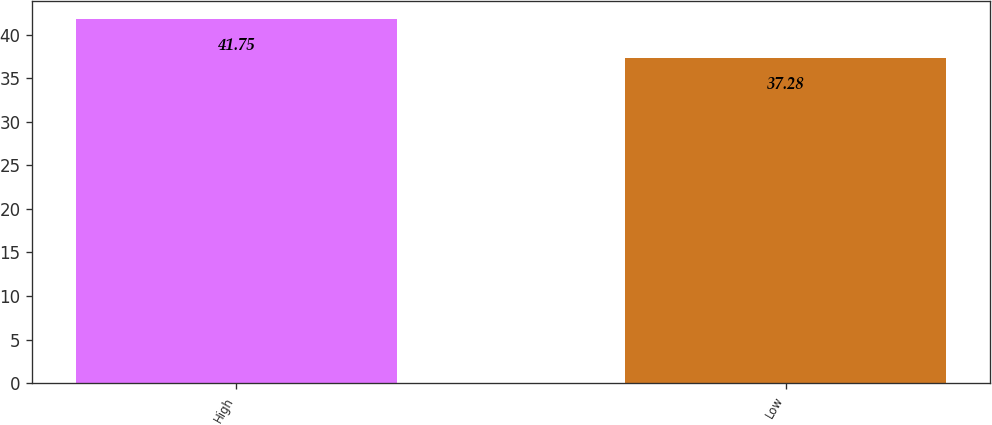Convert chart to OTSL. <chart><loc_0><loc_0><loc_500><loc_500><bar_chart><fcel>High<fcel>Low<nl><fcel>41.75<fcel>37.28<nl></chart> 